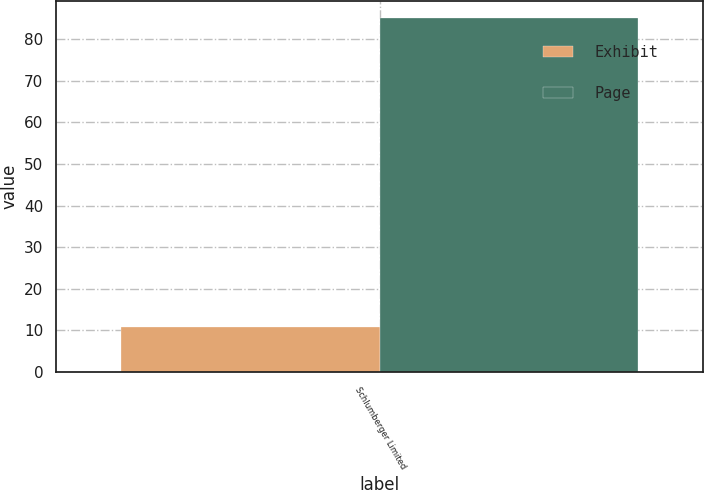Convert chart. <chart><loc_0><loc_0><loc_500><loc_500><stacked_bar_chart><ecel><fcel>Schlumberger Limited<nl><fcel>Exhibit<fcel>10.9<nl><fcel>Page<fcel>85<nl></chart> 